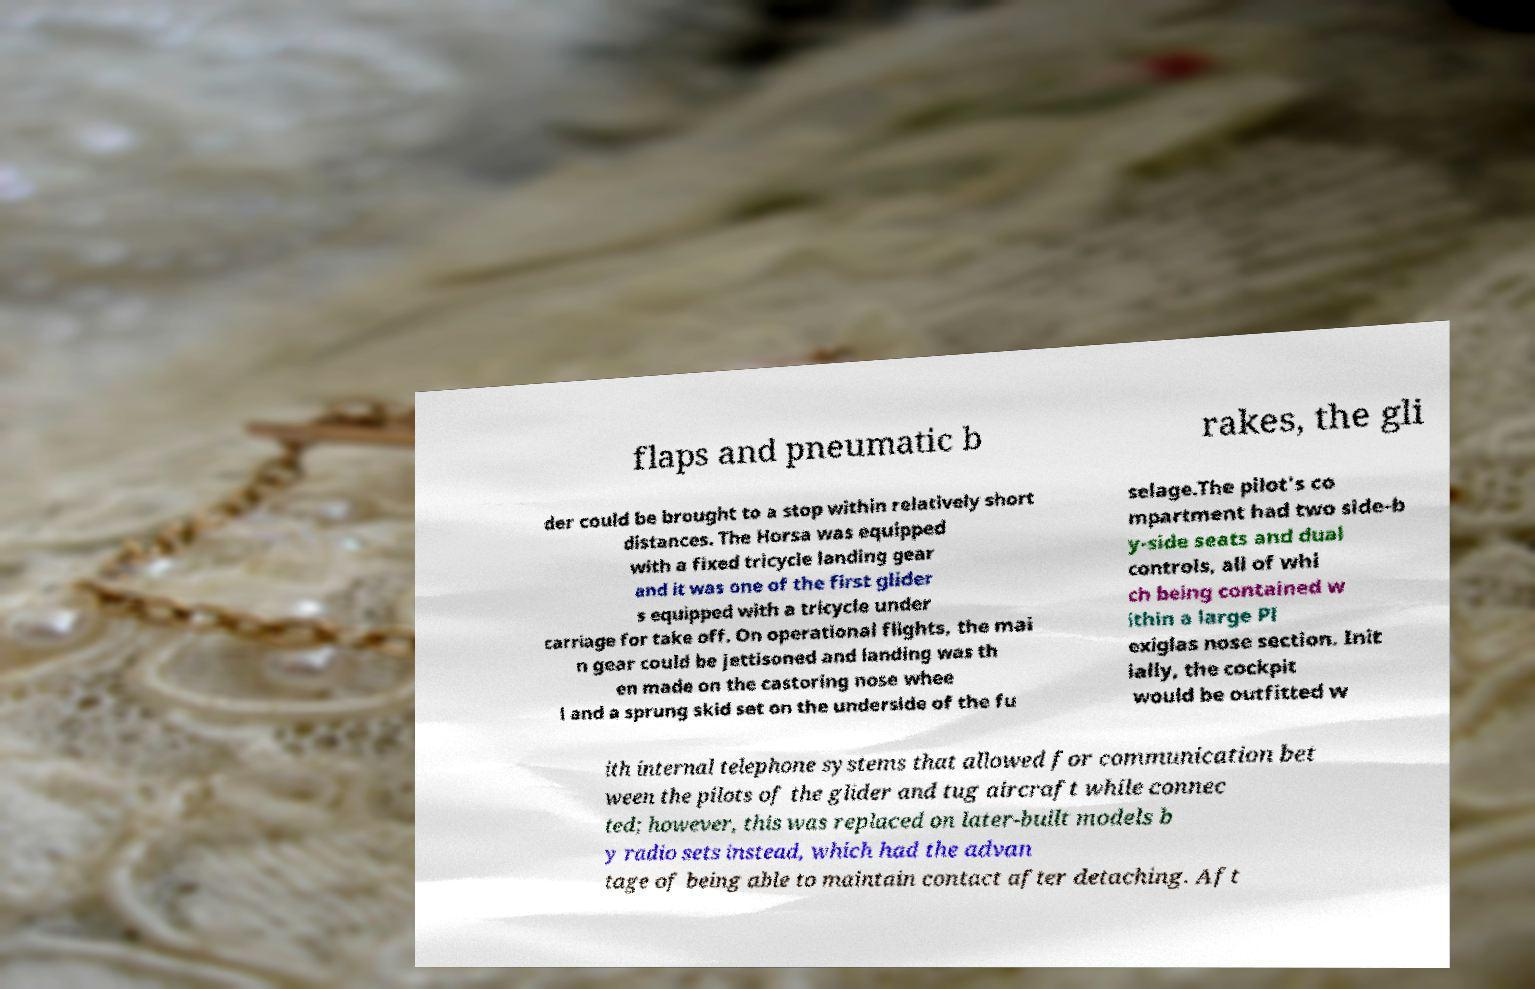Can you read and provide the text displayed in the image?This photo seems to have some interesting text. Can you extract and type it out for me? flaps and pneumatic b rakes, the gli der could be brought to a stop within relatively short distances. The Horsa was equipped with a fixed tricycle landing gear and it was one of the first glider s equipped with a tricycle under carriage for take off. On operational flights, the mai n gear could be jettisoned and landing was th en made on the castoring nose whee l and a sprung skid set on the underside of the fu selage.The pilot's co mpartment had two side-b y-side seats and dual controls, all of whi ch being contained w ithin a large Pl exiglas nose section. Init ially, the cockpit would be outfitted w ith internal telephone systems that allowed for communication bet ween the pilots of the glider and tug aircraft while connec ted; however, this was replaced on later-built models b y radio sets instead, which had the advan tage of being able to maintain contact after detaching. Aft 